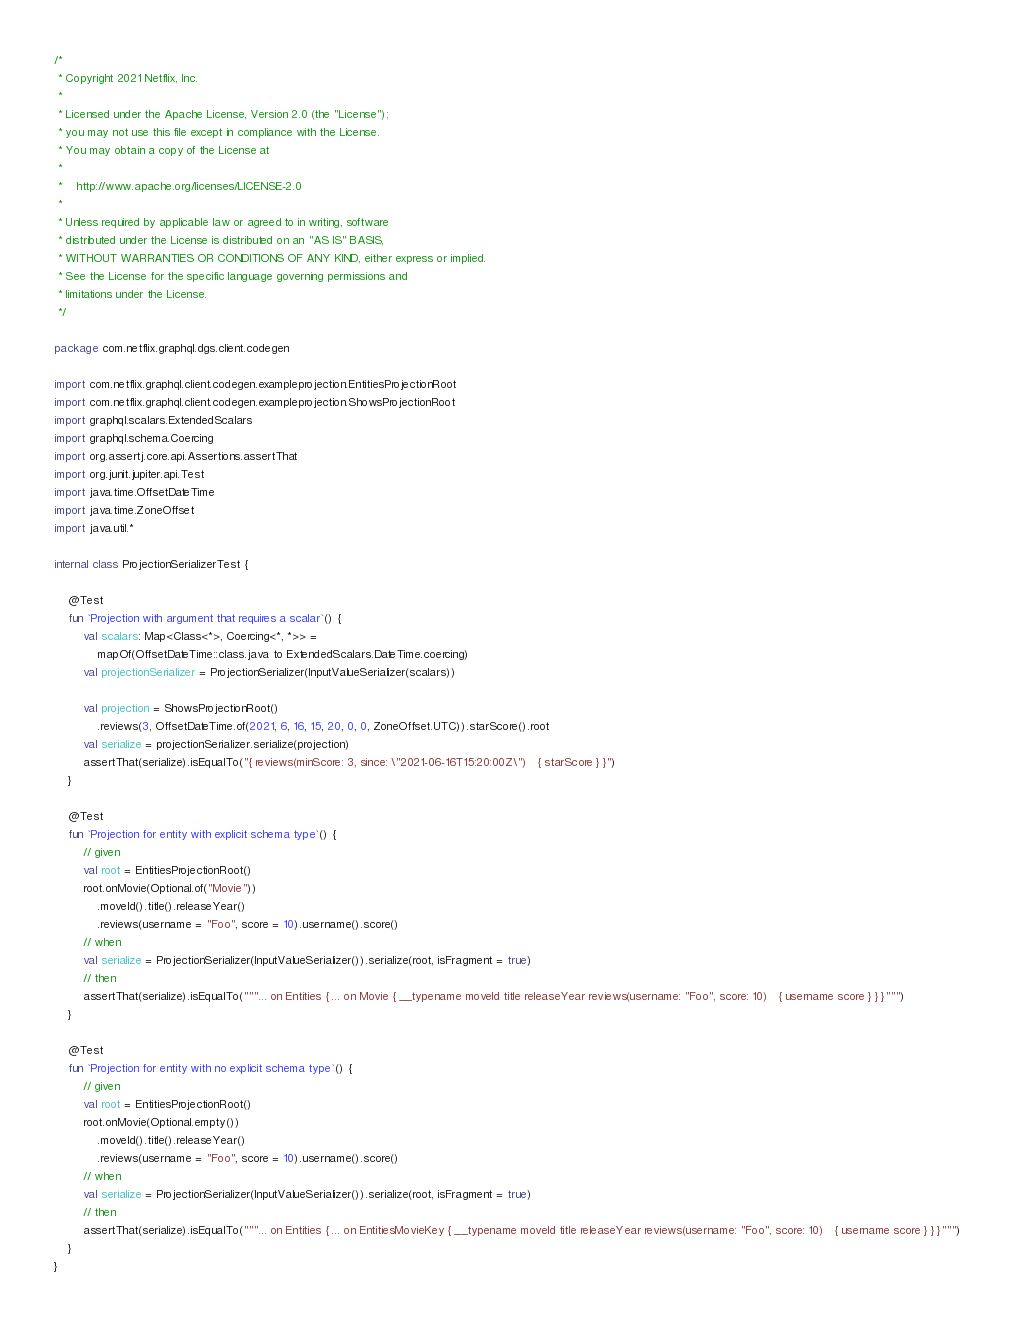<code> <loc_0><loc_0><loc_500><loc_500><_Kotlin_>/*
 * Copyright 2021 Netflix, Inc.
 *
 * Licensed under the Apache License, Version 2.0 (the "License");
 * you may not use this file except in compliance with the License.
 * You may obtain a copy of the License at
 *
 *    http://www.apache.org/licenses/LICENSE-2.0
 *
 * Unless required by applicable law or agreed to in writing, software
 * distributed under the License is distributed on an "AS IS" BASIS,
 * WITHOUT WARRANTIES OR CONDITIONS OF ANY KIND, either express or implied.
 * See the License for the specific language governing permissions and
 * limitations under the License.
 */

package com.netflix.graphql.dgs.client.codegen

import com.netflix.graphql.client.codegen.exampleprojection.EntitiesProjectionRoot
import com.netflix.graphql.client.codegen.exampleprojection.ShowsProjectionRoot
import graphql.scalars.ExtendedScalars
import graphql.schema.Coercing
import org.assertj.core.api.Assertions.assertThat
import org.junit.jupiter.api.Test
import java.time.OffsetDateTime
import java.time.ZoneOffset
import java.util.*

internal class ProjectionSerializerTest {

    @Test
    fun `Projection with argument that requires a scalar`() {
        val scalars: Map<Class<*>, Coercing<*, *>> =
            mapOf(OffsetDateTime::class.java to ExtendedScalars.DateTime.coercing)
        val projectionSerializer = ProjectionSerializer(InputValueSerializer(scalars))

        val projection = ShowsProjectionRoot()
            .reviews(3, OffsetDateTime.of(2021, 6, 16, 15, 20, 0, 0, ZoneOffset.UTC)).starScore().root
        val serialize = projectionSerializer.serialize(projection)
        assertThat(serialize).isEqualTo("{ reviews(minScore: 3, since: \"2021-06-16T15:20:00Z\")   { starScore } }")
    }

    @Test
    fun `Projection for entity with explicit schema type`() {
        // given
        val root = EntitiesProjectionRoot()
        root.onMovie(Optional.of("Movie"))
            .moveId().title().releaseYear()
            .reviews(username = "Foo", score = 10).username().score()
        // when
        val serialize = ProjectionSerializer(InputValueSerializer()).serialize(root, isFragment = true)
        // then
        assertThat(serialize).isEqualTo("""... on Entities { ... on Movie { __typename moveId title releaseYear reviews(username: "Foo", score: 10)   { username score } } }""")
    }

    @Test
    fun `Projection for entity with no explicit schema type`() {
        // given
        val root = EntitiesProjectionRoot()
        root.onMovie(Optional.empty())
            .moveId().title().releaseYear()
            .reviews(username = "Foo", score = 10).username().score()
        // when
        val serialize = ProjectionSerializer(InputValueSerializer()).serialize(root, isFragment = true)
        // then
        assertThat(serialize).isEqualTo("""... on Entities { ... on EntitiesMovieKey { __typename moveId title releaseYear reviews(username: "Foo", score: 10)   { username score } } }""")
    }
}
</code> 